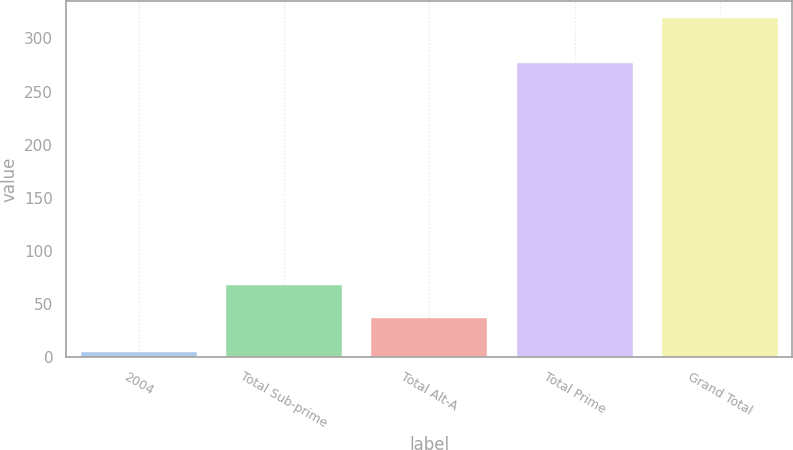<chart> <loc_0><loc_0><loc_500><loc_500><bar_chart><fcel>2004<fcel>Total Sub-prime<fcel>Total Alt-A<fcel>Total Prime<fcel>Grand Total<nl><fcel>5<fcel>67.8<fcel>36.4<fcel>277<fcel>319<nl></chart> 